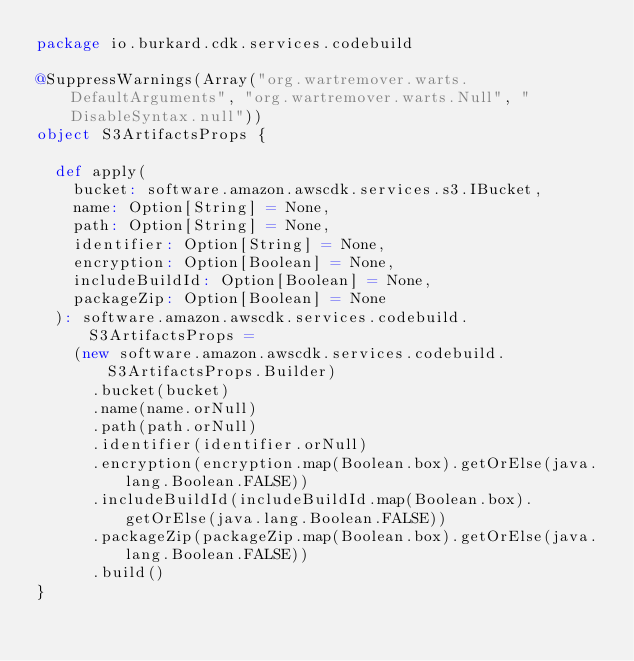<code> <loc_0><loc_0><loc_500><loc_500><_Scala_>package io.burkard.cdk.services.codebuild

@SuppressWarnings(Array("org.wartremover.warts.DefaultArguments", "org.wartremover.warts.Null", "DisableSyntax.null"))
object S3ArtifactsProps {

  def apply(
    bucket: software.amazon.awscdk.services.s3.IBucket,
    name: Option[String] = None,
    path: Option[String] = None,
    identifier: Option[String] = None,
    encryption: Option[Boolean] = None,
    includeBuildId: Option[Boolean] = None,
    packageZip: Option[Boolean] = None
  ): software.amazon.awscdk.services.codebuild.S3ArtifactsProps =
    (new software.amazon.awscdk.services.codebuild.S3ArtifactsProps.Builder)
      .bucket(bucket)
      .name(name.orNull)
      .path(path.orNull)
      .identifier(identifier.orNull)
      .encryption(encryption.map(Boolean.box).getOrElse(java.lang.Boolean.FALSE))
      .includeBuildId(includeBuildId.map(Boolean.box).getOrElse(java.lang.Boolean.FALSE))
      .packageZip(packageZip.map(Boolean.box).getOrElse(java.lang.Boolean.FALSE))
      .build()
}
</code> 